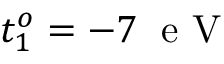<formula> <loc_0><loc_0><loc_500><loc_500>t _ { 1 } ^ { o } = - 7 \, e V</formula> 